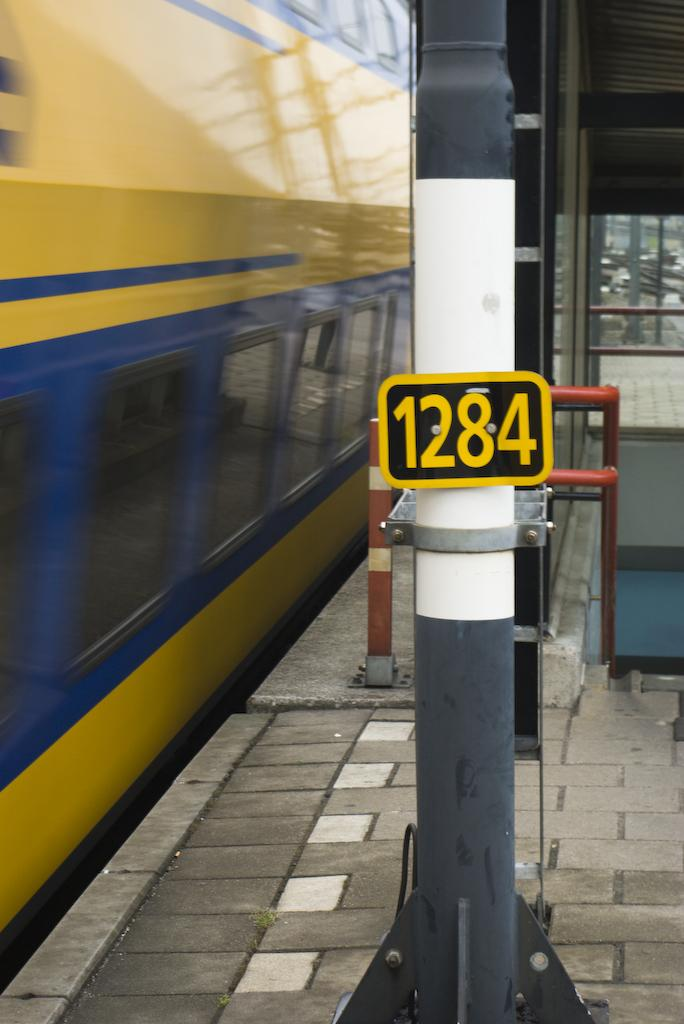<image>
Present a compact description of the photo's key features. The small black and yellow sign reads 1284 